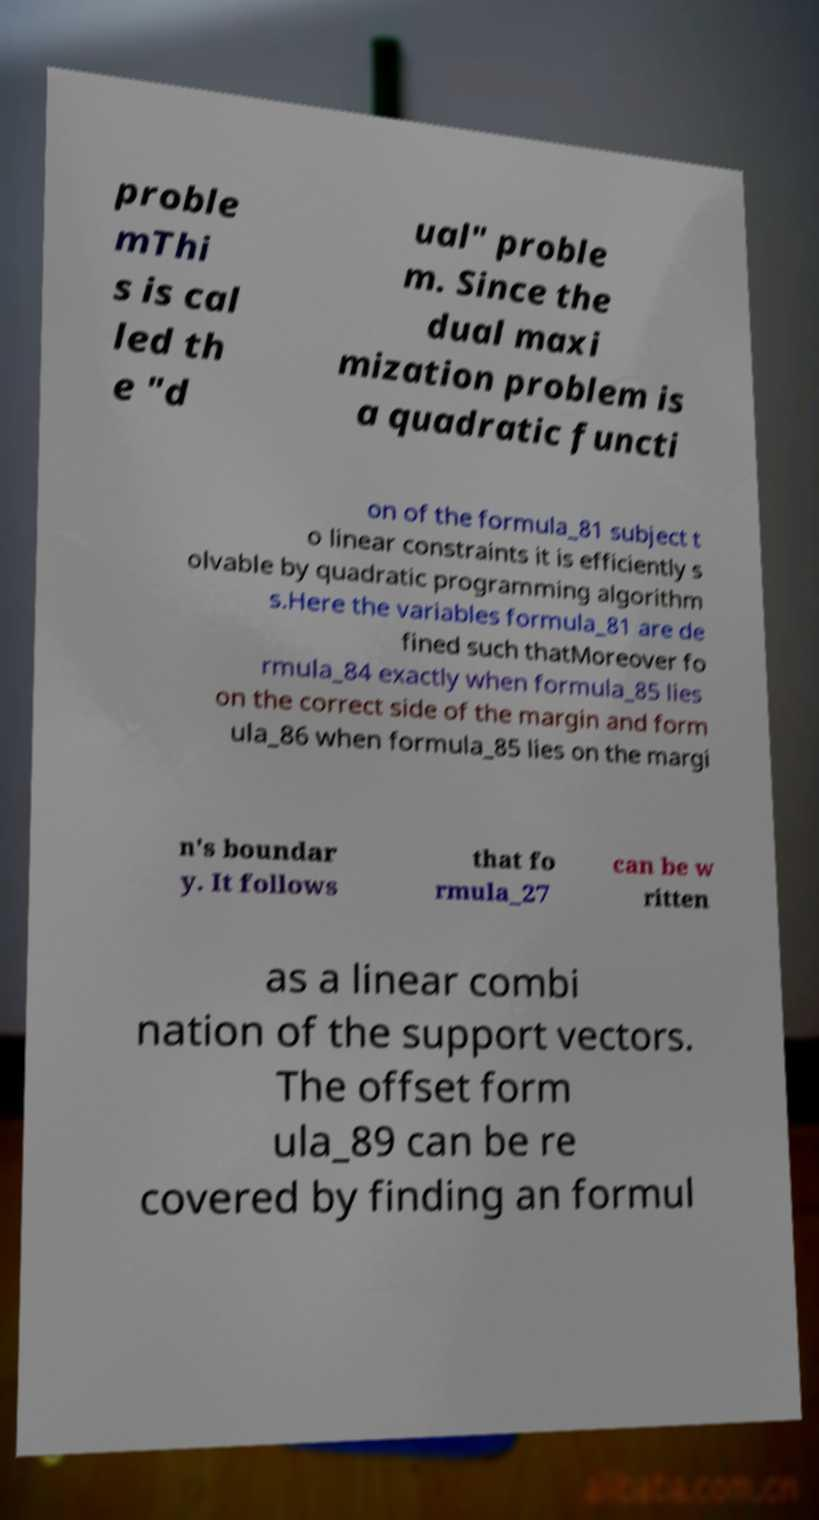Could you assist in decoding the text presented in this image and type it out clearly? proble mThi s is cal led th e "d ual" proble m. Since the dual maxi mization problem is a quadratic functi on of the formula_81 subject t o linear constraints it is efficiently s olvable by quadratic programming algorithm s.Here the variables formula_81 are de fined such thatMoreover fo rmula_84 exactly when formula_85 lies on the correct side of the margin and form ula_86 when formula_85 lies on the margi n's boundar y. It follows that fo rmula_27 can be w ritten as a linear combi nation of the support vectors. The offset form ula_89 can be re covered by finding an formul 